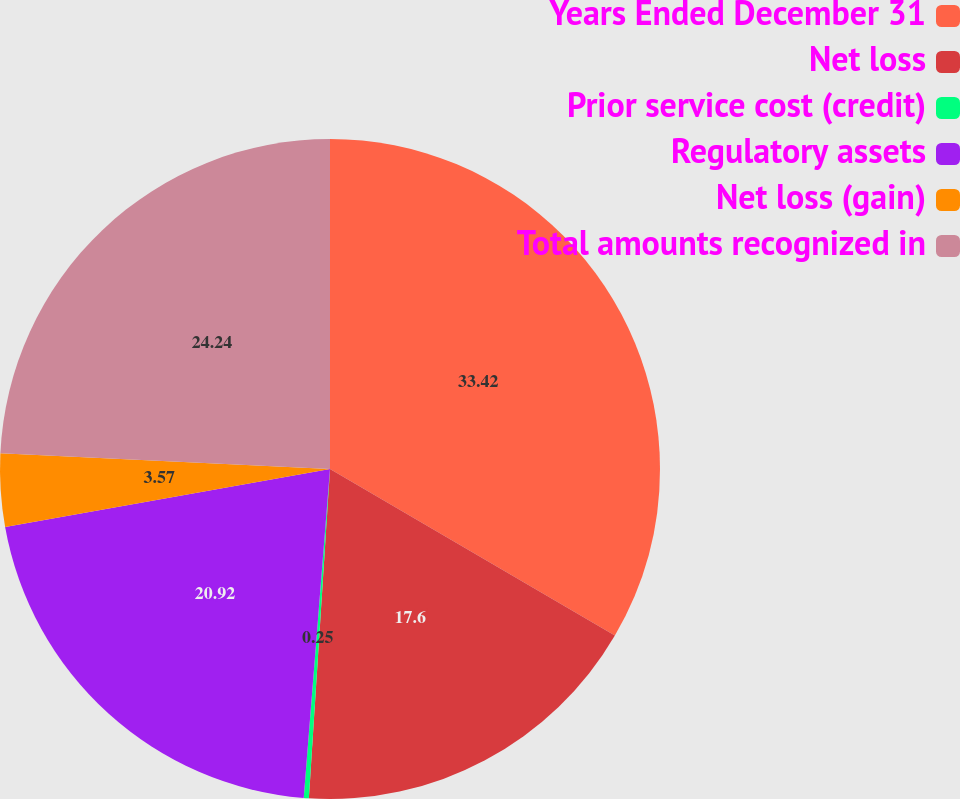<chart> <loc_0><loc_0><loc_500><loc_500><pie_chart><fcel>Years Ended December 31<fcel>Net loss<fcel>Prior service cost (credit)<fcel>Regulatory assets<fcel>Net loss (gain)<fcel>Total amounts recognized in<nl><fcel>33.42%<fcel>17.6%<fcel>0.25%<fcel>20.92%<fcel>3.57%<fcel>24.24%<nl></chart> 